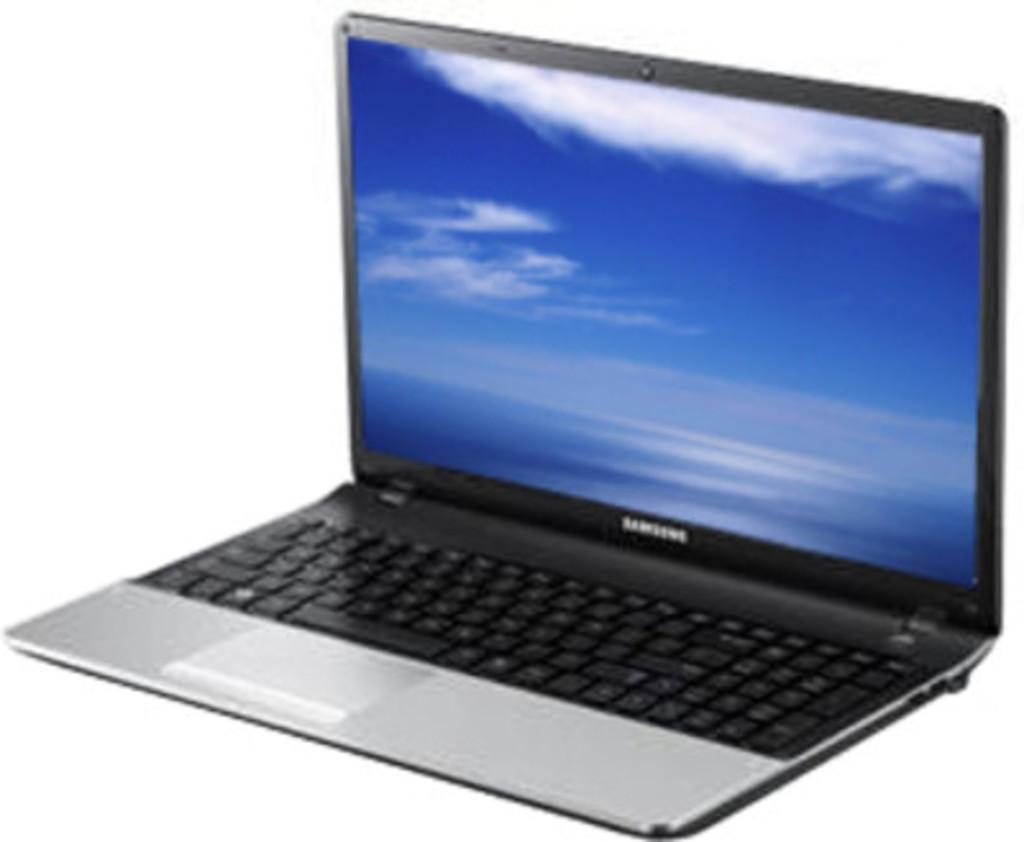What brand of laptop is this?
Your response must be concise. Samsung. Is this a samsung laptop?
Provide a short and direct response. Yes. 